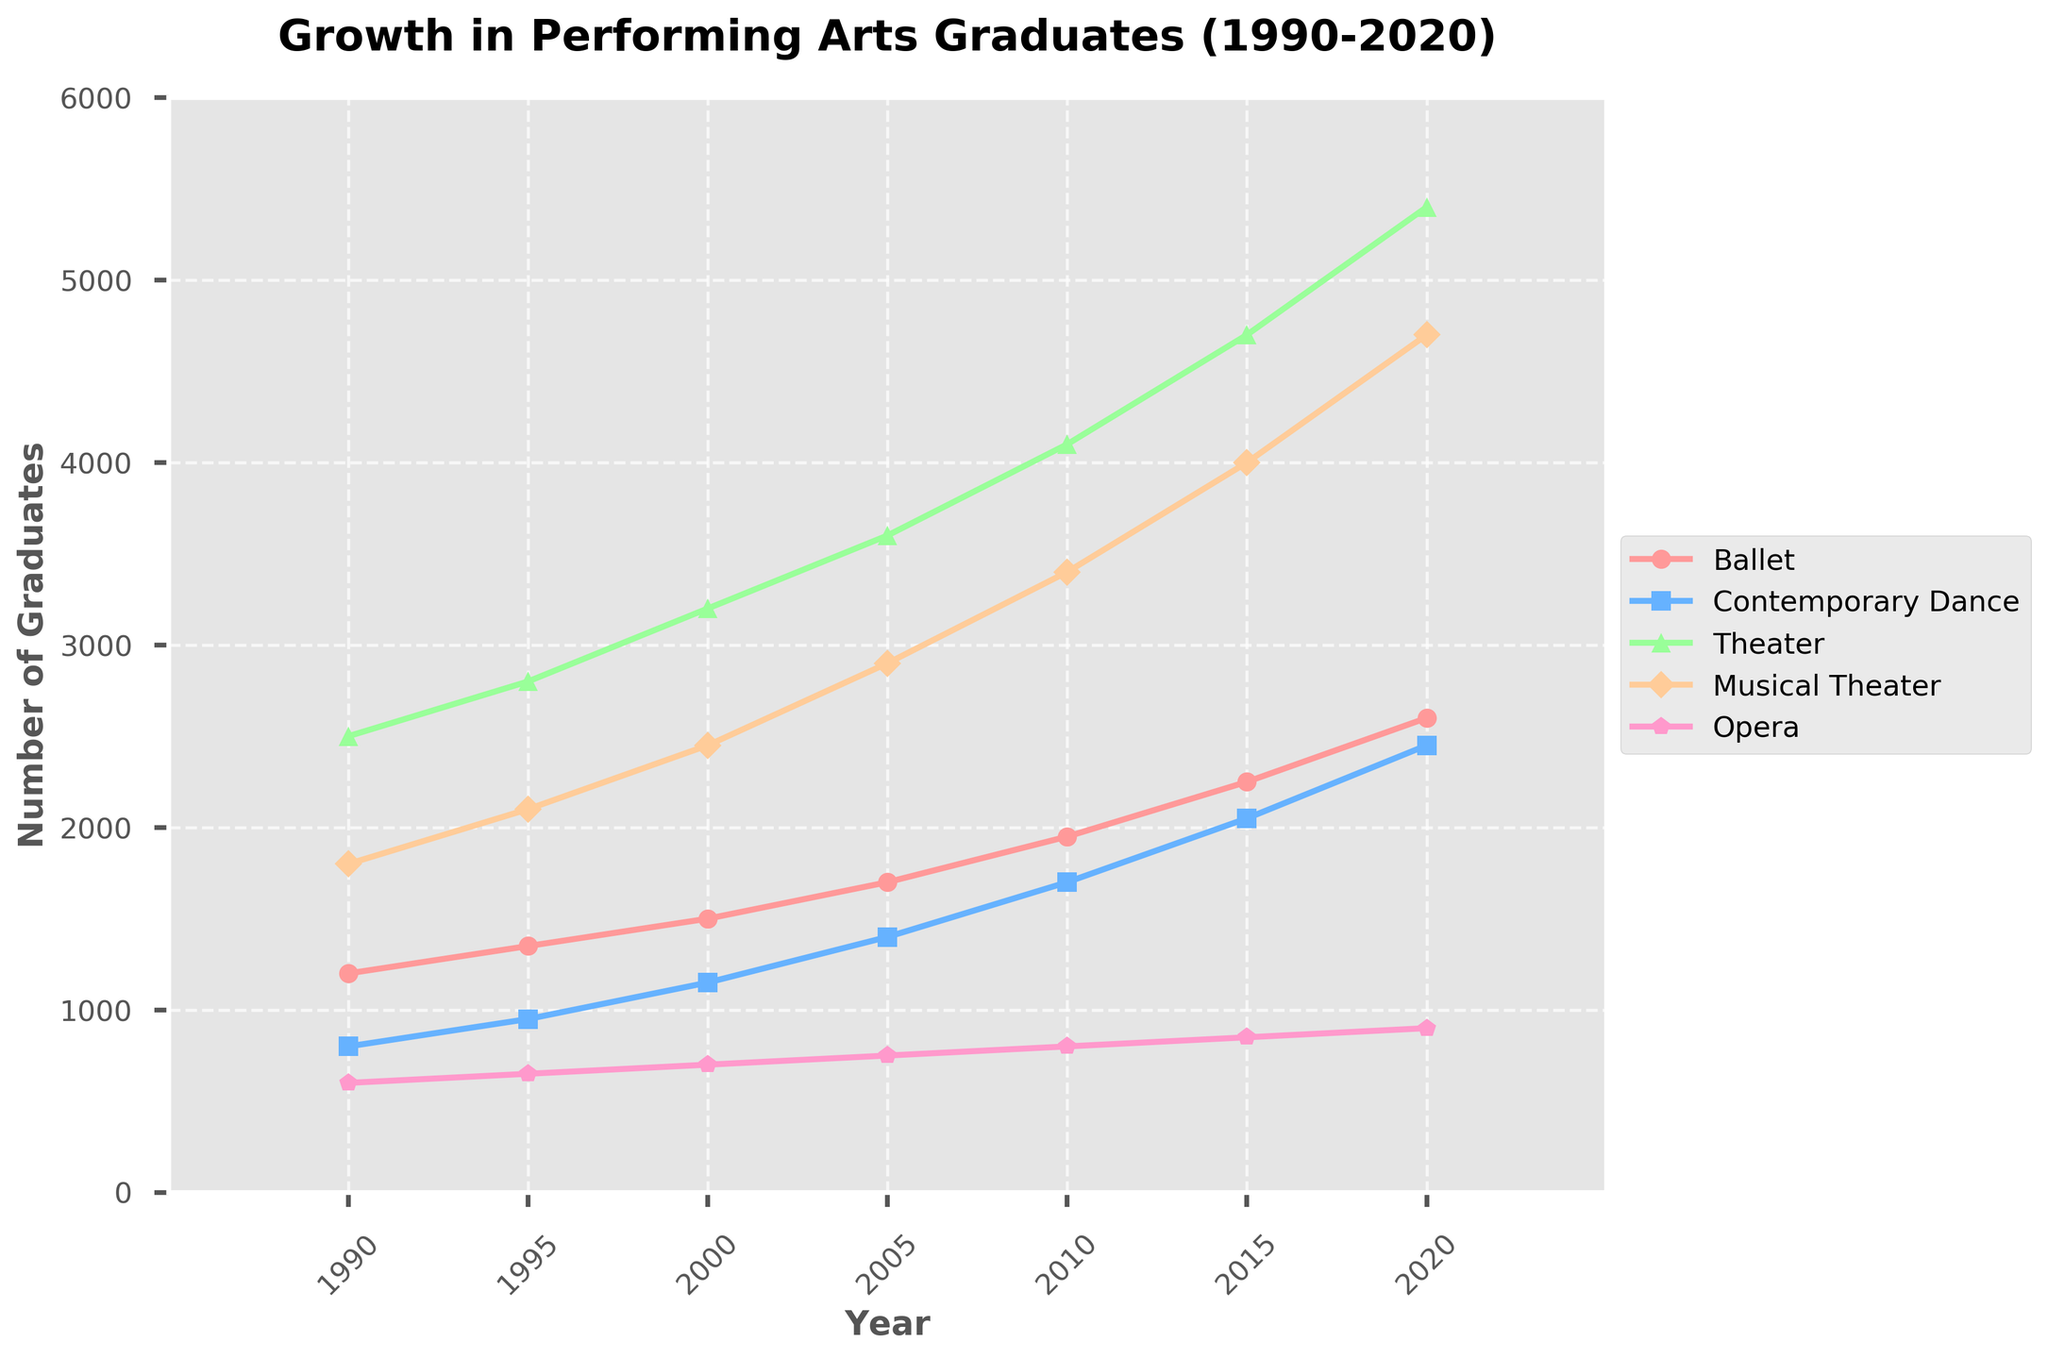What is the trend of the number of Ballet graduates from 1990 to 2020? The number of Ballet graduates shows a consistent upward trend from 1200 in 1990 to 2600 in 2020, increasing approximately every 5 years.
Answer: Consistent upward trend Which discipline had the highest number of graduates in 2020? Observing the last point of each line, Theater had the highest number of graduates in 2020, reaching 5400.
Answer: Theater How did the number of Contemporary Dance graduates change from 1990 to 2010? The number of Contemporary Dance graduates increased from 800 in 1990 to 1700 in 2010.
Answer: Increased by 900 Compare the growth rates between Musical Theater and Opera from 1990 to 2020. Musical Theater grew from 1800 in 1990 to 4700 in 2020, adding 2900 graduates. Opera grew from 600 in 1990 to 900 in 2020, adding 300 graduates. Therefore, Musical Theater had a higher growth rate.
Answer: Musical Theater had a higher growth rate Which two disciplines showed the most similar growth patterns? Both Ballet and Contemporary Dance have lines with a similar upward slope and rates of increase, showing comparable growth patterns.
Answer: Ballet and Contemporary Dance What is the difference in the number of Theater and Opera graduates in 2020? In 2020, Theater graduates were 5400 and Opera graduates were 900. The difference is 5400 - 900 = 4500.
Answer: 4500 What is the average number of Ballet graduates over the 30-year period? Summing the number of Ballet graduates (1200 + 1350 + 1500 + 1700 + 1950 + 2250 + 2600) = 12550. Dividing by 7 (the number of data points), the average is 12550 / 7 ≈ 1793.
Answer: 1793 Which discipline had the second-highest number of graduates in 2015? Observing the data points for 2015, Theater had the highest (4700), and Musical Theater had the second-highest with 4000 graduates.
Answer: Musical Theater By how much did the number of Musical Theater graduates increase from 2000 to 2015? The number of Musical Theater graduates in 2000 was 2450 and in 2015 it was 4000. The increase is 4000 - 2450 = 1550.
Answer: 1550 Which discipline shows the least variation in the number of graduates from 1990 to 2020? Opera shows the least variation, ranging from 600 graduates in 1990 to 900 in 2020, a difference of 300.
Answer: Opera 